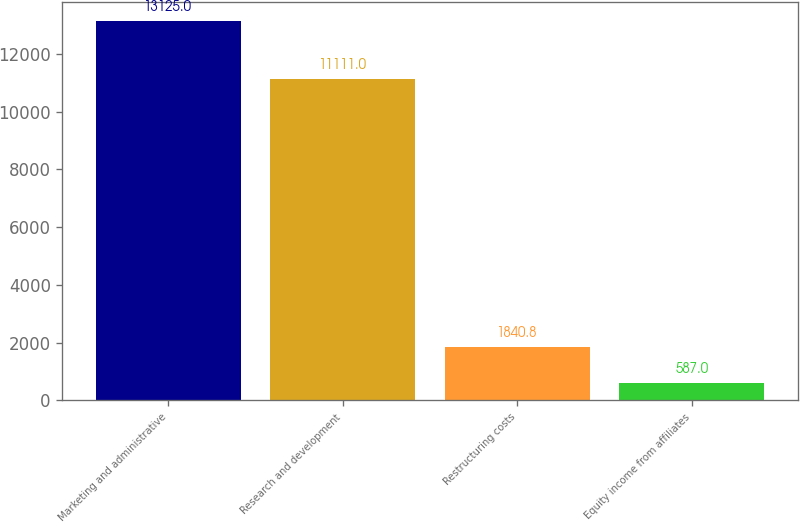<chart> <loc_0><loc_0><loc_500><loc_500><bar_chart><fcel>Marketing and administrative<fcel>Research and development<fcel>Restructuring costs<fcel>Equity income from affiliates<nl><fcel>13125<fcel>11111<fcel>1840.8<fcel>587<nl></chart> 